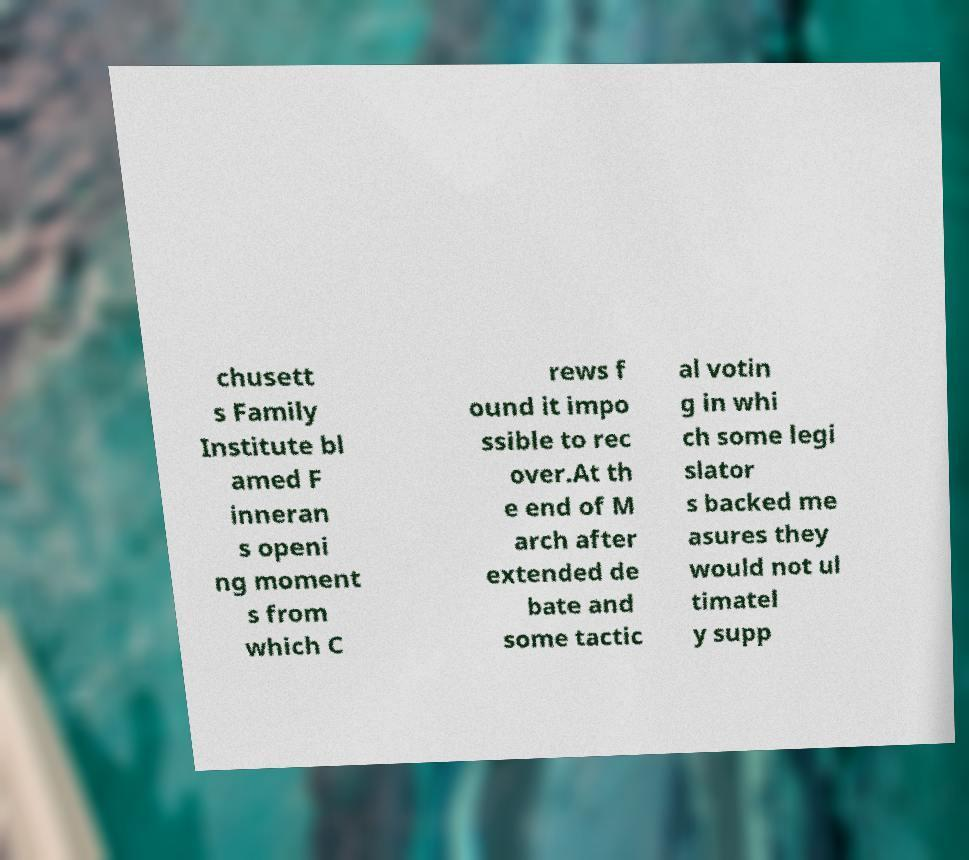Please read and relay the text visible in this image. What does it say? chusett s Family Institute bl amed F inneran s openi ng moment s from which C rews f ound it impo ssible to rec over.At th e end of M arch after extended de bate and some tactic al votin g in whi ch some legi slator s backed me asures they would not ul timatel y supp 